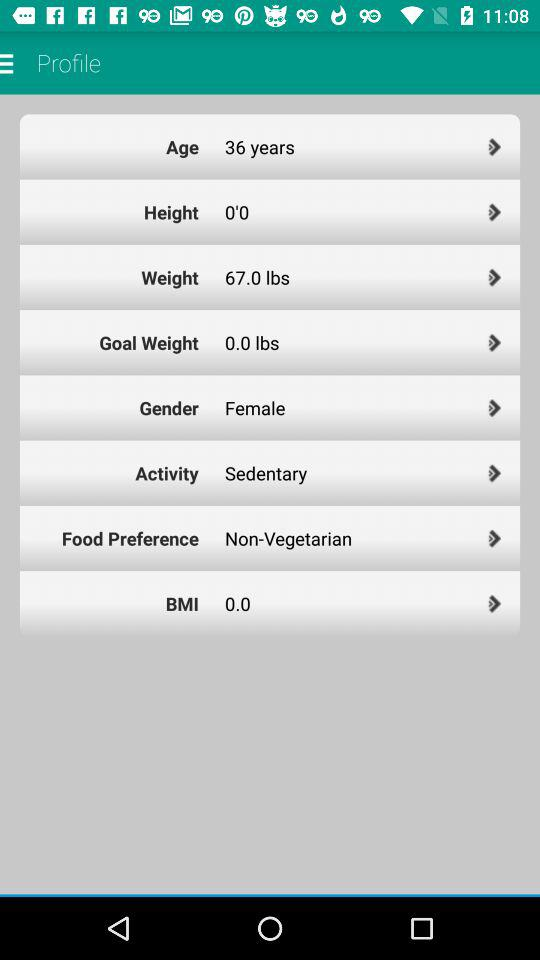What is the weight of the person? The weight of the person is 67 lbs. 